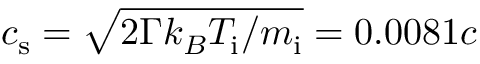<formula> <loc_0><loc_0><loc_500><loc_500>c _ { s } = \sqrt { 2 \Gamma k _ { B } T _ { i } / m _ { i } } = 0 . 0 0 8 1 c</formula> 